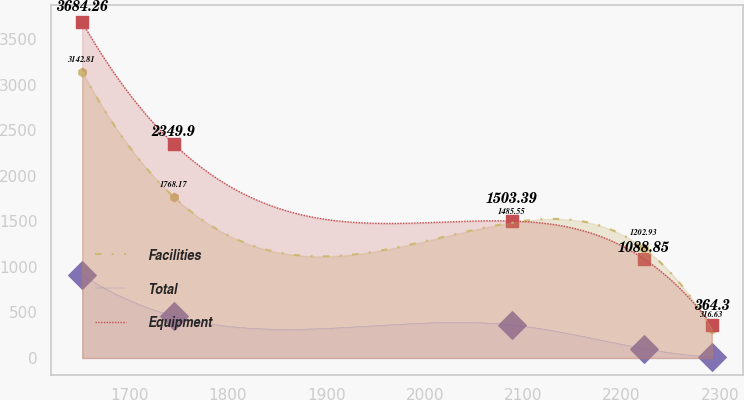<chart> <loc_0><loc_0><loc_500><loc_500><line_chart><ecel><fcel>Facilities<fcel>Total<fcel>Equipment<nl><fcel>1651.73<fcel>3142.81<fcel>911.26<fcel>3684.26<nl><fcel>1744.8<fcel>1768.17<fcel>460.73<fcel>2349.9<nl><fcel>2088.61<fcel>1485.55<fcel>363.46<fcel>1503.39<nl><fcel>2222.79<fcel>1202.93<fcel>103.67<fcel>1088.85<nl><fcel>2291.87<fcel>316.63<fcel>13.94<fcel>364.3<nl></chart> 